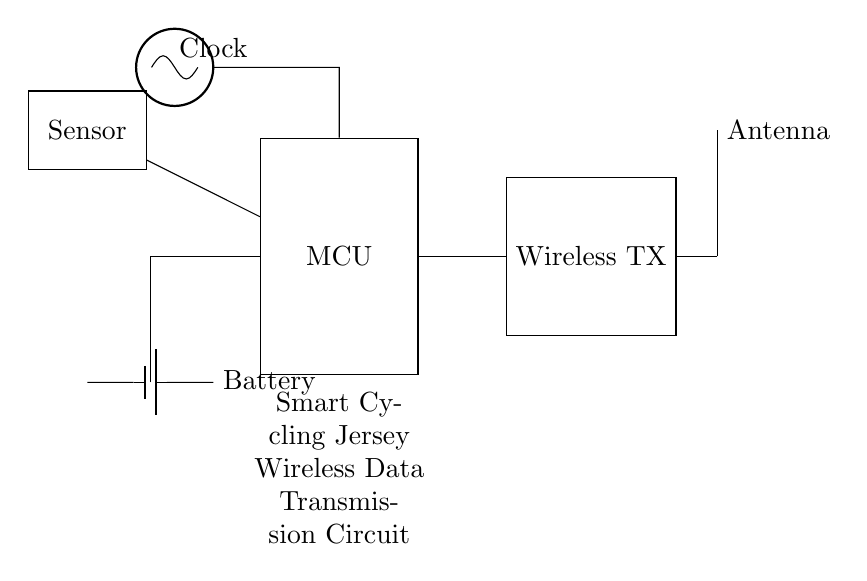What is the primary function of the MCU in this circuit? The MCU, or microcontroller, processes the data from the sensor and sends it to the wireless transmitter. It acts as the central control unit of the circuit.
Answer: Processing data What components are involved in the wireless data transmission? The components involved include the MCU, wireless transmitter, and antenna. They work together to transmit data wirelessly from the sensor.
Answer: MCU, Wireless TX, Antenna How is the battery connected in this circuit? The battery is connected to the MCU for power supply. The drawing indicates that the connection is made with a line drawn from the battery to the MCU.
Answer: Powered to MCU What type of sensor is represented in the circuit diagram? The specific type of sensor is not indicated, but it is labeled simply as "Sensor." Its actual type would depend on the application (e.g., heart rate, temperature, etc.).
Answer: Sensor What role does the clock play in this circuit? The clock provides timing signals to the MCU, which is critical for ensuring that data is processed at the correct times. It helps in synchronizing operations within the circuit.
Answer: Timing signals What is the direction of data flow in this circuit? Data flows from the sensor to the MCU and then to the wireless transmitter for transmission. This flow is indicated by the arrows or lines connecting the components.
Answer: Sensor to MCU to TX Which component is responsible for converting data to radio signals? The wireless transmitter is responsible for converting processed data from the MCU into radio signals for wireless transmission.
Answer: Wireless TX 